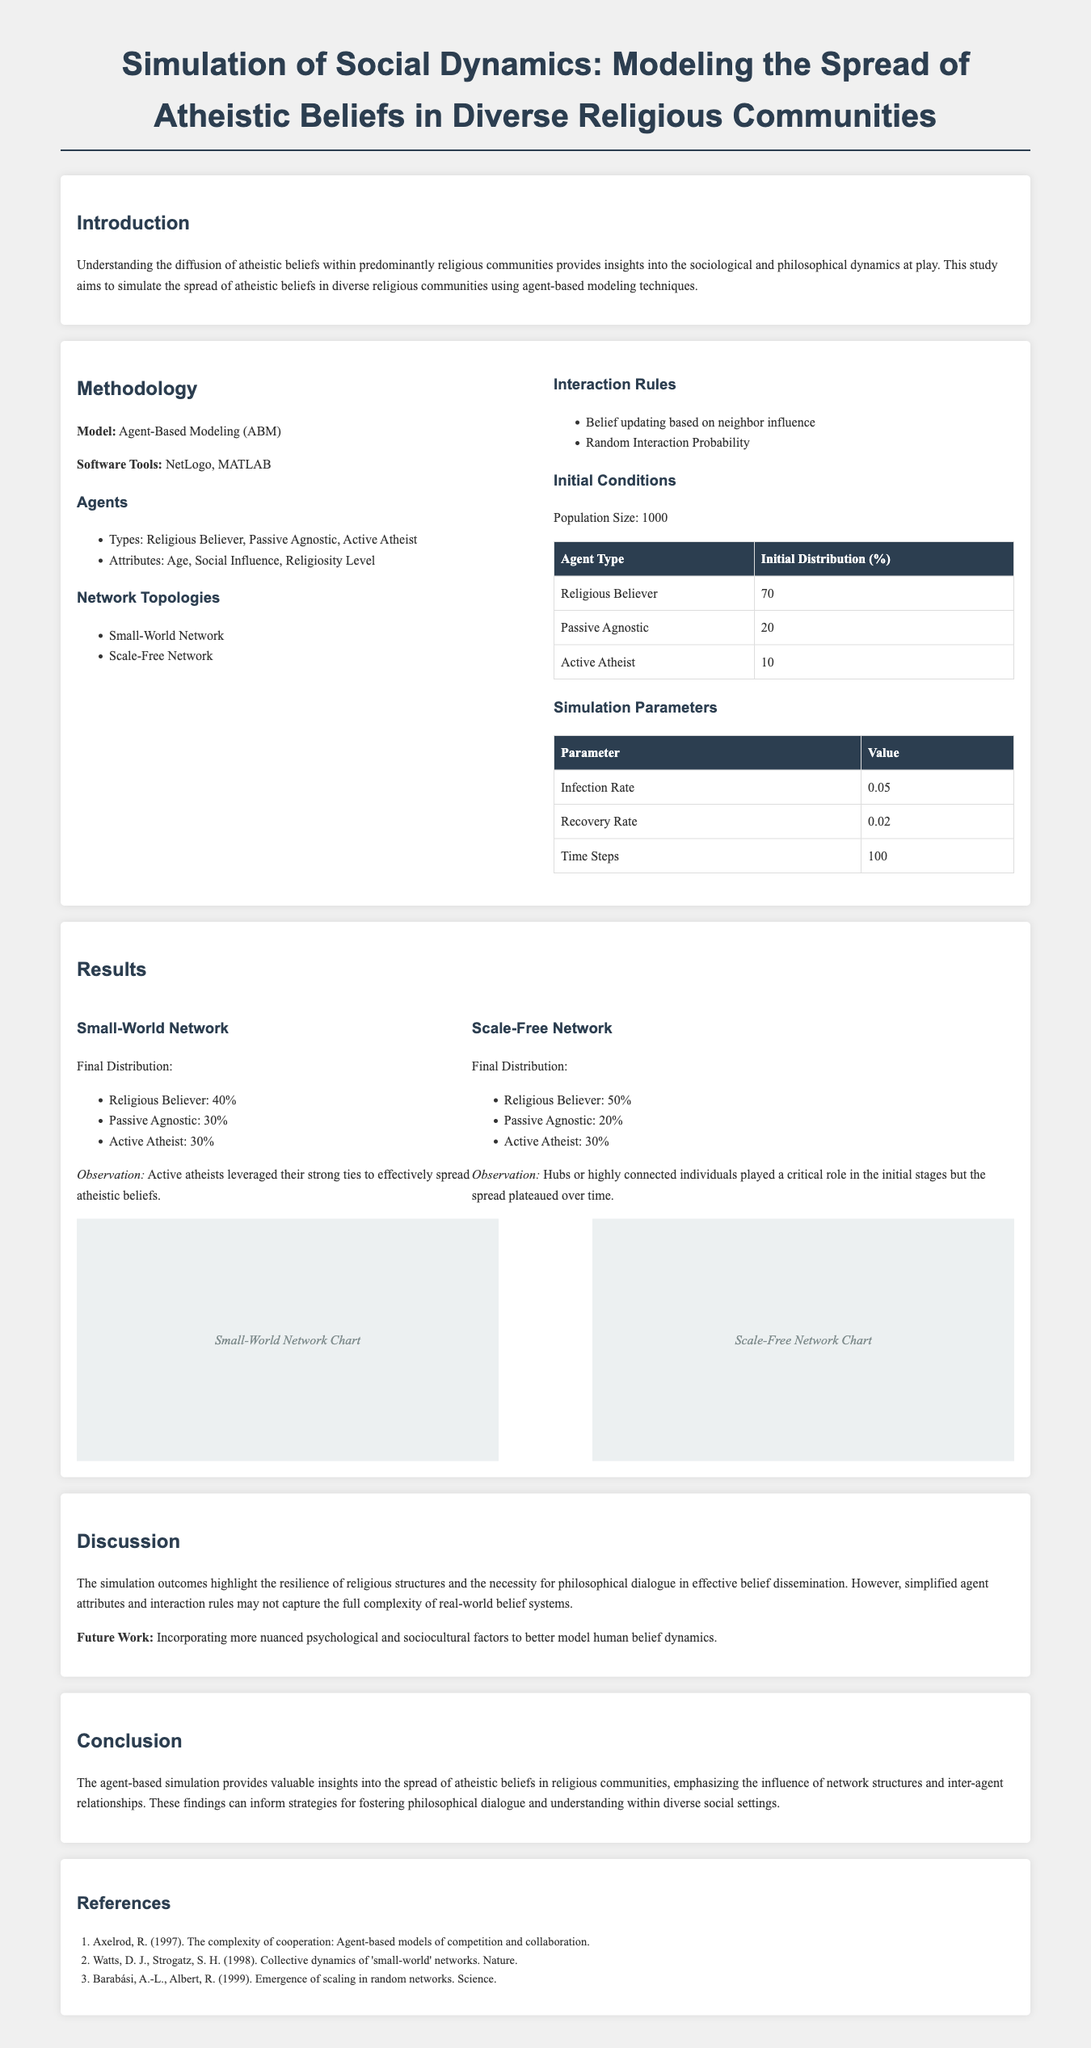what type of modeling technique is used in the study? The study uses agent-based modeling techniques to simulate the spread of atheistic beliefs.
Answer: Agent-Based Modeling what is the initial percentage of Religious Believers in the population? The initial distribution of Religious Believers is specified in a table showing percentages, which is 70%.
Answer: 70% what was the total population size for the simulation? The document states that the population size for the simulation is clearly outlined in the methodology section.
Answer: 1000 what conclusion is drawn about the resilience of religious structures? The conclusion highlights that religious structures demonstrate resilience, as indicated in the discussion section.
Answer: Resilience which software tools were used in the simulation? The document lists the software tools utilized for the simulation in the methodology section.
Answer: NetLogo, MATLAB how did the final distribution of Active Atheists compare in both network types? Final distributions for Active Atheists are mentioned for both network types, indicating their percentages in each scenario.
Answer: 30% what future work is suggested to improve the simulation? The document mentions incorporating more nuanced psychological and sociocultural factors as a suggestion for future work.
Answer: Nuanced psychological and sociocultural factors what is the observation made regarding Active Atheists in the Small-World Network? The observation about Active Atheists in the Small-World Network highlights their strong ties affecting the spread of beliefs.
Answer: Strong ties what is the infection rate specified in the simulation parameters? The simulation parameters include a table listing the infection rate among other values clearly.
Answer: 0.05 